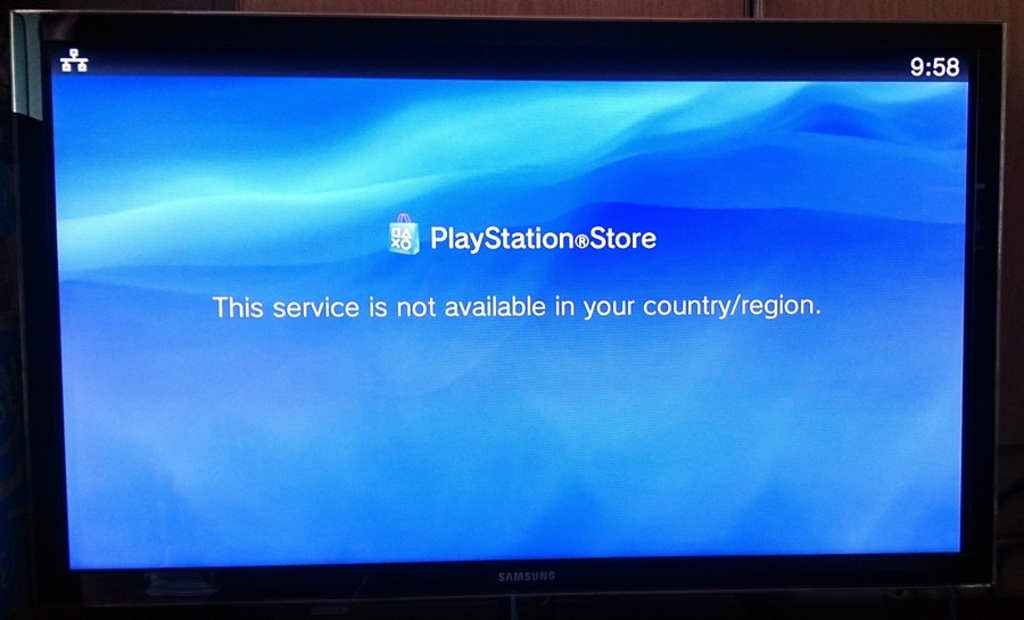Can you provide more context about region-locked content? Certainly. Region-locked content is a practice where a digital service restricts access to its content based on a user's geographical location. This can be due to licensing agreements where content creators provide exclusive rights to distribute their products in defined areas, or to comply with local taxation and censorship laws. While this practice can protect intellectual property rights and adhere to legal requirements, it can also lead to customer dissatisfaction, as seen in this image where a user is barred from accessing the PlayStation Store. 